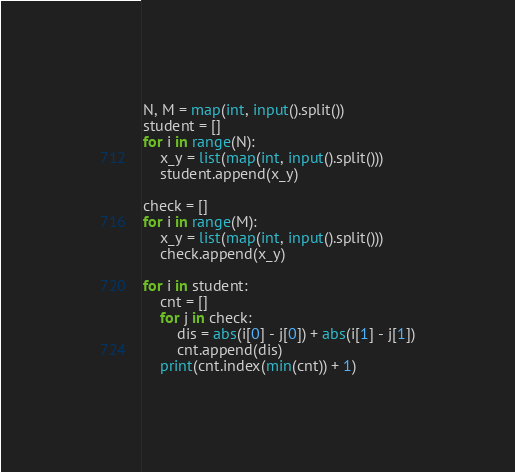<code> <loc_0><loc_0><loc_500><loc_500><_Python_>N, M = map(int, input().split())
student = []
for i in range(N):
    x_y = list(map(int, input().split()))
    student.append(x_y)
    
check = []
for i in range(M):
    x_y = list(map(int, input().split()))
    check.append(x_y)
    
for i in student:
    cnt = []
    for j in check:
        dis = abs(i[0] - j[0]) + abs(i[1] - j[1])
        cnt.append(dis)
    print(cnt.index(min(cnt)) + 1)</code> 